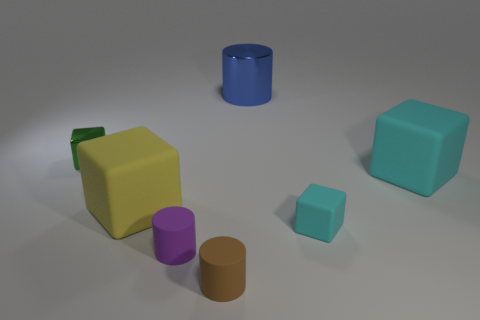Add 2 large cyan rubber objects. How many objects exist? 9 Subtract all large yellow matte blocks. How many blocks are left? 3 Subtract 2 cubes. How many cubes are left? 2 Subtract all cyan cylinders. How many cyan blocks are left? 2 Subtract all blocks. How many objects are left? 3 Subtract all brown cylinders. How many cylinders are left? 2 Subtract 0 brown cubes. How many objects are left? 7 Subtract all yellow cylinders. Subtract all cyan blocks. How many cylinders are left? 3 Subtract all small cyan objects. Subtract all yellow rubber blocks. How many objects are left? 5 Add 3 big cylinders. How many big cylinders are left? 4 